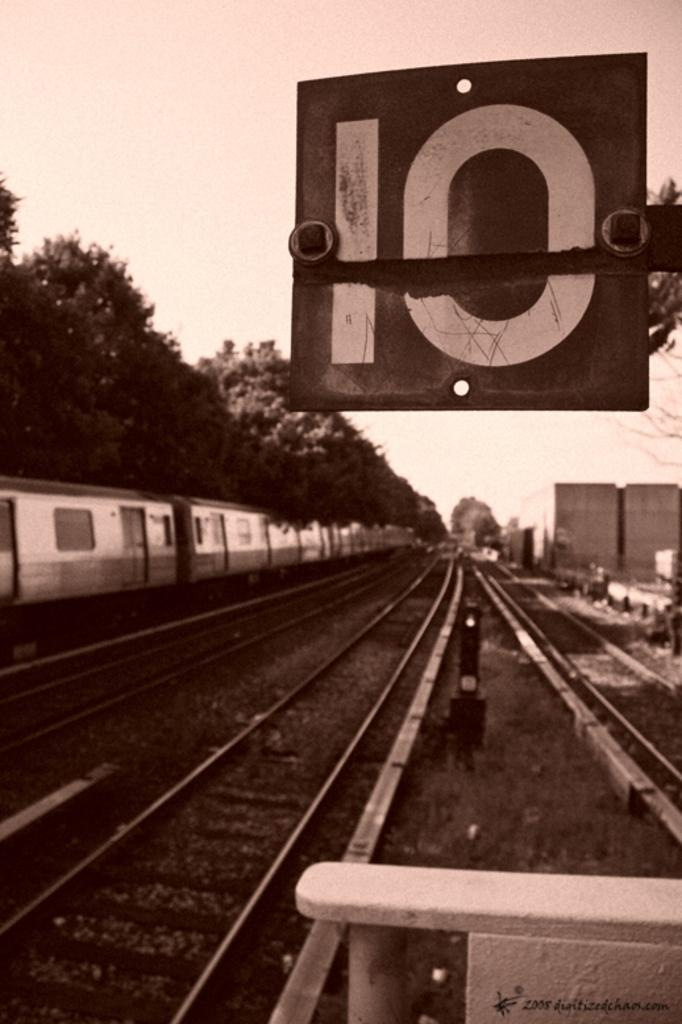<image>
Give a short and clear explanation of the subsequent image. The number ten hangs from a sign next to a train track. 